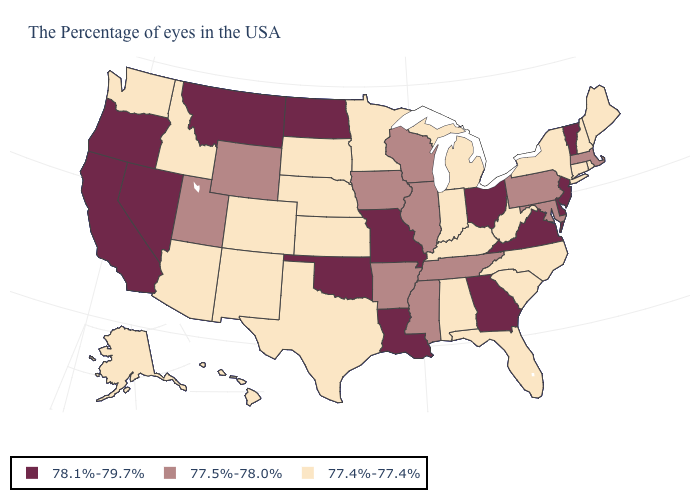Does North Dakota have a higher value than Kansas?
Give a very brief answer. Yes. Does North Carolina have the same value as Minnesota?
Short answer required. Yes. What is the value of Mississippi?
Short answer required. 77.5%-78.0%. What is the value of Utah?
Keep it brief. 77.5%-78.0%. What is the highest value in the MidWest ?
Write a very short answer. 78.1%-79.7%. Name the states that have a value in the range 77.4%-77.4%?
Give a very brief answer. Maine, Rhode Island, New Hampshire, Connecticut, New York, North Carolina, South Carolina, West Virginia, Florida, Michigan, Kentucky, Indiana, Alabama, Minnesota, Kansas, Nebraska, Texas, South Dakota, Colorado, New Mexico, Arizona, Idaho, Washington, Alaska, Hawaii. Name the states that have a value in the range 77.4%-77.4%?
Give a very brief answer. Maine, Rhode Island, New Hampshire, Connecticut, New York, North Carolina, South Carolina, West Virginia, Florida, Michigan, Kentucky, Indiana, Alabama, Minnesota, Kansas, Nebraska, Texas, South Dakota, Colorado, New Mexico, Arizona, Idaho, Washington, Alaska, Hawaii. What is the lowest value in the USA?
Write a very short answer. 77.4%-77.4%. What is the value of Missouri?
Quick response, please. 78.1%-79.7%. Does Georgia have the highest value in the South?
Concise answer only. Yes. Does Iowa have the lowest value in the USA?
Be succinct. No. Name the states that have a value in the range 77.4%-77.4%?
Write a very short answer. Maine, Rhode Island, New Hampshire, Connecticut, New York, North Carolina, South Carolina, West Virginia, Florida, Michigan, Kentucky, Indiana, Alabama, Minnesota, Kansas, Nebraska, Texas, South Dakota, Colorado, New Mexico, Arizona, Idaho, Washington, Alaska, Hawaii. What is the value of Iowa?
Write a very short answer. 77.5%-78.0%. Which states have the highest value in the USA?
Answer briefly. Vermont, New Jersey, Delaware, Virginia, Ohio, Georgia, Louisiana, Missouri, Oklahoma, North Dakota, Montana, Nevada, California, Oregon. Does New Jersey have the lowest value in the Northeast?
Keep it brief. No. 